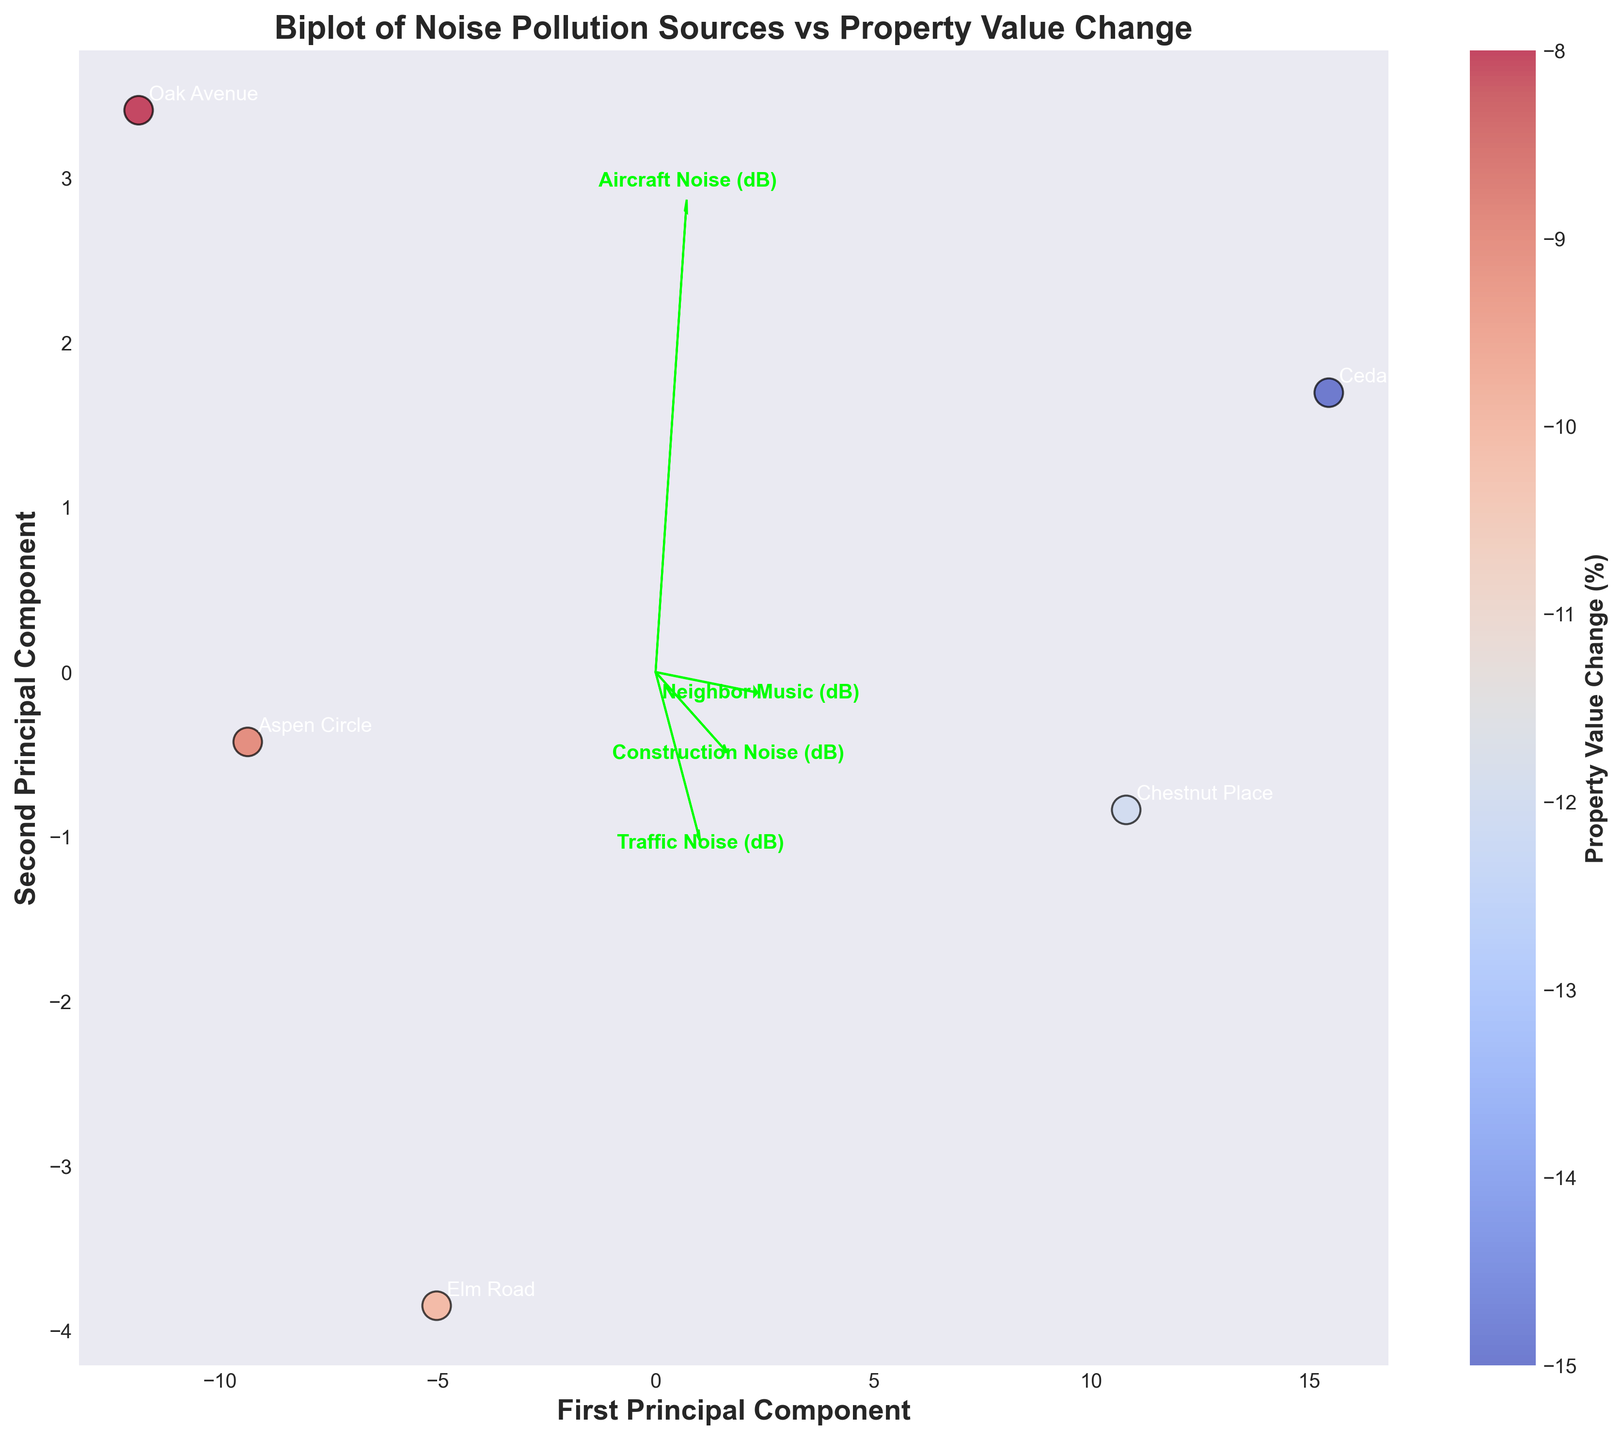What is the title of the plot? The title of the plot is always located at the top center of the graph. This title provides a brief description of the figure's purpose. In this plot, the title is clearly stated at the top.
Answer: Biplot of Noise Pollution Sources vs Property Value Change Which axis indicates the First Principal Component? The x-axis typically represents the first principal component in a biplot. This is stated in the label of the x-axis.
Answer: The x-axis How many locations are plotted on the biplot? Each point represents a different location, and the locations are annotated on the plot. By counting the annotations, we can determine how many locations are displayed.
Answer: 5 What is the range of Property Value Change (%) shown on the colorbar? The color bar represents the Property Value Change (%) values. By examining the color bar on the right side of the plot, we can identify its range.
Answer: -15% to -8% Which noise source most strongly influences the first principal component? The influence of each noise source on the principal components can be inferred from the projection arrows and their lengths. The source with the longest arrow in the direction of the first principal component has the strongest influence.
Answer: Construction Noise Compare the impact on property values between Cedar Court and Elm Road. By locating the points for Cedar Court and Elm Road, we can check the color associated with each point, which reflects their property value changes. Cedar Court is indicated with a color representing a greater negative change compared to Elm Road. This suggests a larger decrease in property value for Cedar Court.
Answer: Cedar Court has a greater negative impact on property values than Elm Road Which location has the highest value along the second principal component? We can determine this by identifying the point that is positioned the highest on the y-axis, which represents the second principal component.
Answer: Cedar Court What relationship can be observed between Traffic Noise and Property Value Change? The relationship is illustrated by the direction and length of the arrow representing Traffic Noise. By examining the scatterplot and colorbar, correlations can be inferred whether areas with higher traffic noise tend to have greater negative changes in property values.
Answer: Higher Traffic Noise correlates with more negative Property Value Change How does Aircraft Noise compare to Neighbor Music in terms of influence on the first principal component? The influence is indicated by the length of the arrows for each source along the first principal component. The one with the longer arrow has a stronger influence.
Answer: Aircraft Noise has a stronger influence 